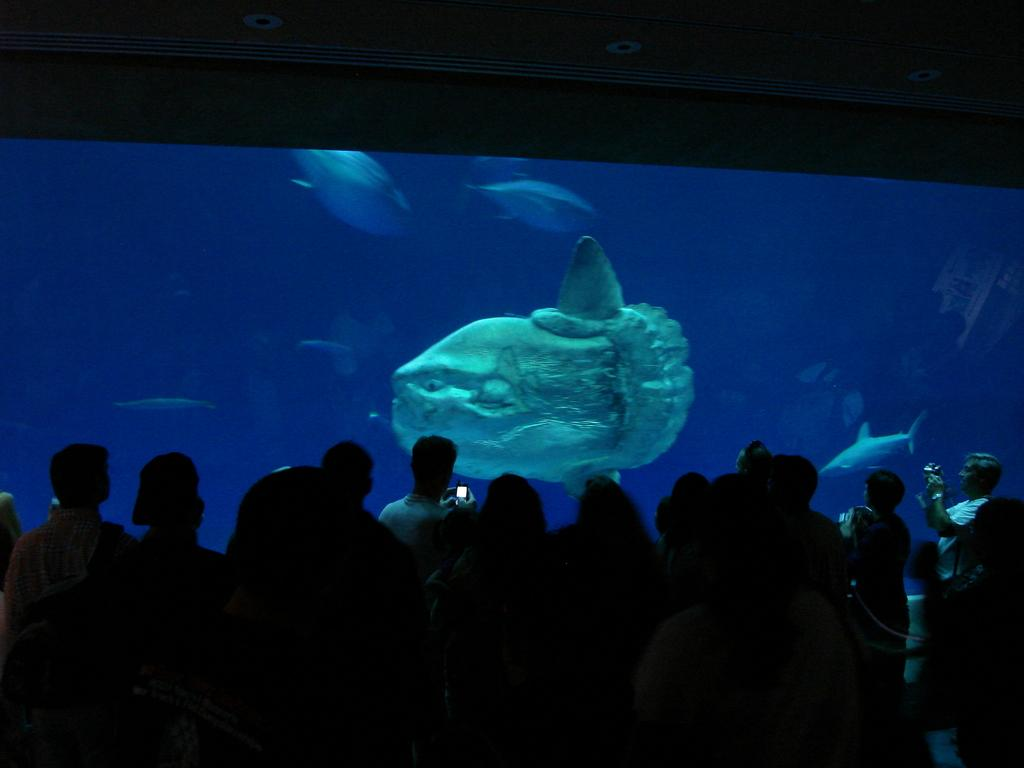How many people are in the image? There is a group of people in the image, but the exact number is not specified. What are the people in the image doing? The people are standing in the image. What can be seen behind the glass in the water? There are fishes behind a glass in the water. What is visible at the top of the image? There is a roof visible at the top of the image. What grade is the guitar being played in the image? There is no guitar present in the image, so it is not possible to determine the grade being played. 